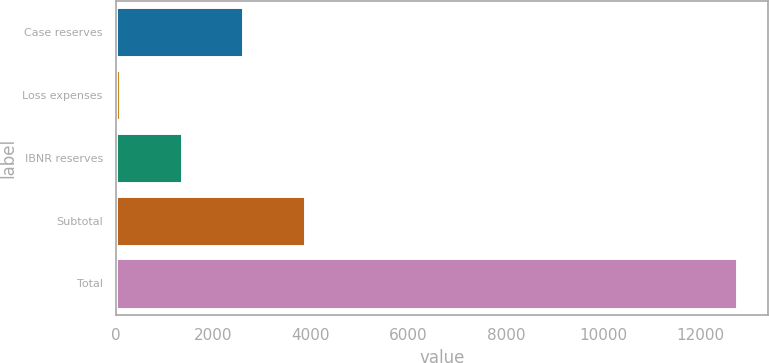Convert chart. <chart><loc_0><loc_0><loc_500><loc_500><bar_chart><fcel>Case reserves<fcel>Loss expenses<fcel>IBNR reserves<fcel>Subtotal<fcel>Total<nl><fcel>2613.8<fcel>81<fcel>1347.4<fcel>3880.2<fcel>12745<nl></chart> 